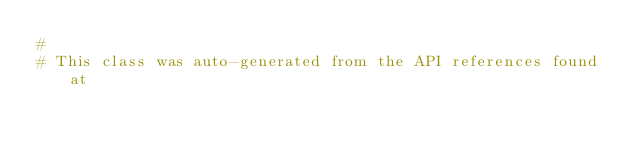Convert code to text. <code><loc_0><loc_0><loc_500><loc_500><_Ruby_>#
# This class was auto-generated from the API references found at</code> 